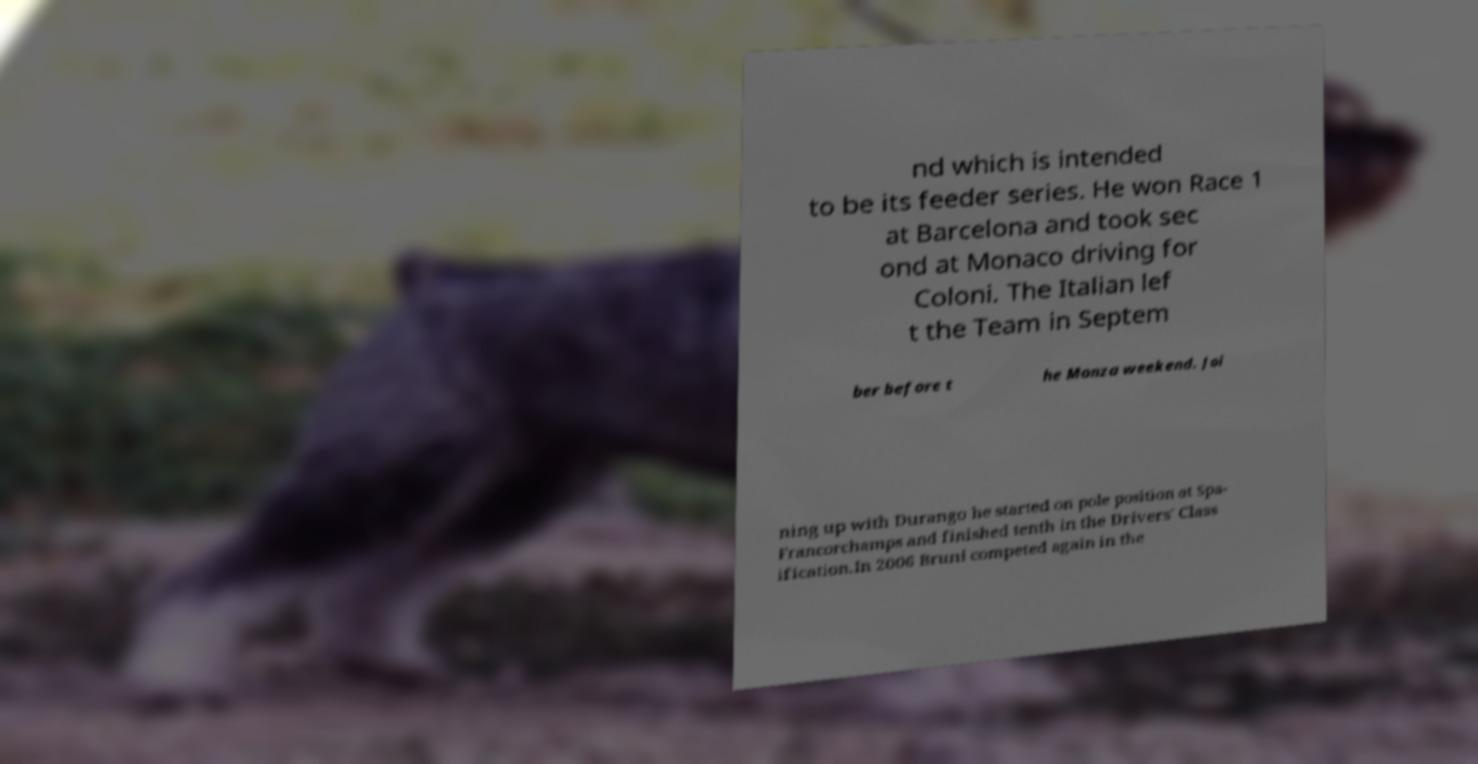Can you read and provide the text displayed in the image?This photo seems to have some interesting text. Can you extract and type it out for me? nd which is intended to be its feeder series. He won Race 1 at Barcelona and took sec ond at Monaco driving for Coloni. The Italian lef t the Team in Septem ber before t he Monza weekend. Joi ning up with Durango he started on pole position at Spa- Francorchamps and finished tenth in the Drivers' Class ification.In 2006 Bruni competed again in the 